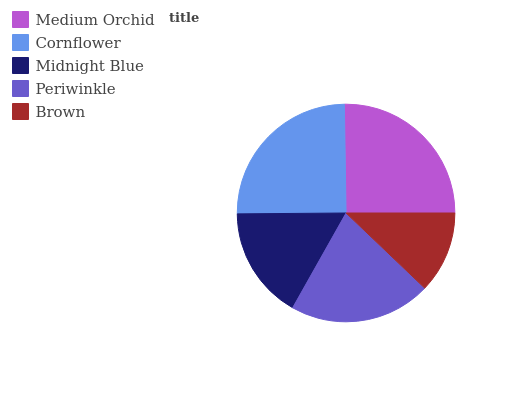Is Brown the minimum?
Answer yes or no. Yes. Is Medium Orchid the maximum?
Answer yes or no. Yes. Is Cornflower the minimum?
Answer yes or no. No. Is Cornflower the maximum?
Answer yes or no. No. Is Medium Orchid greater than Cornflower?
Answer yes or no. Yes. Is Cornflower less than Medium Orchid?
Answer yes or no. Yes. Is Cornflower greater than Medium Orchid?
Answer yes or no. No. Is Medium Orchid less than Cornflower?
Answer yes or no. No. Is Periwinkle the high median?
Answer yes or no. Yes. Is Periwinkle the low median?
Answer yes or no. Yes. Is Cornflower the high median?
Answer yes or no. No. Is Midnight Blue the low median?
Answer yes or no. No. 